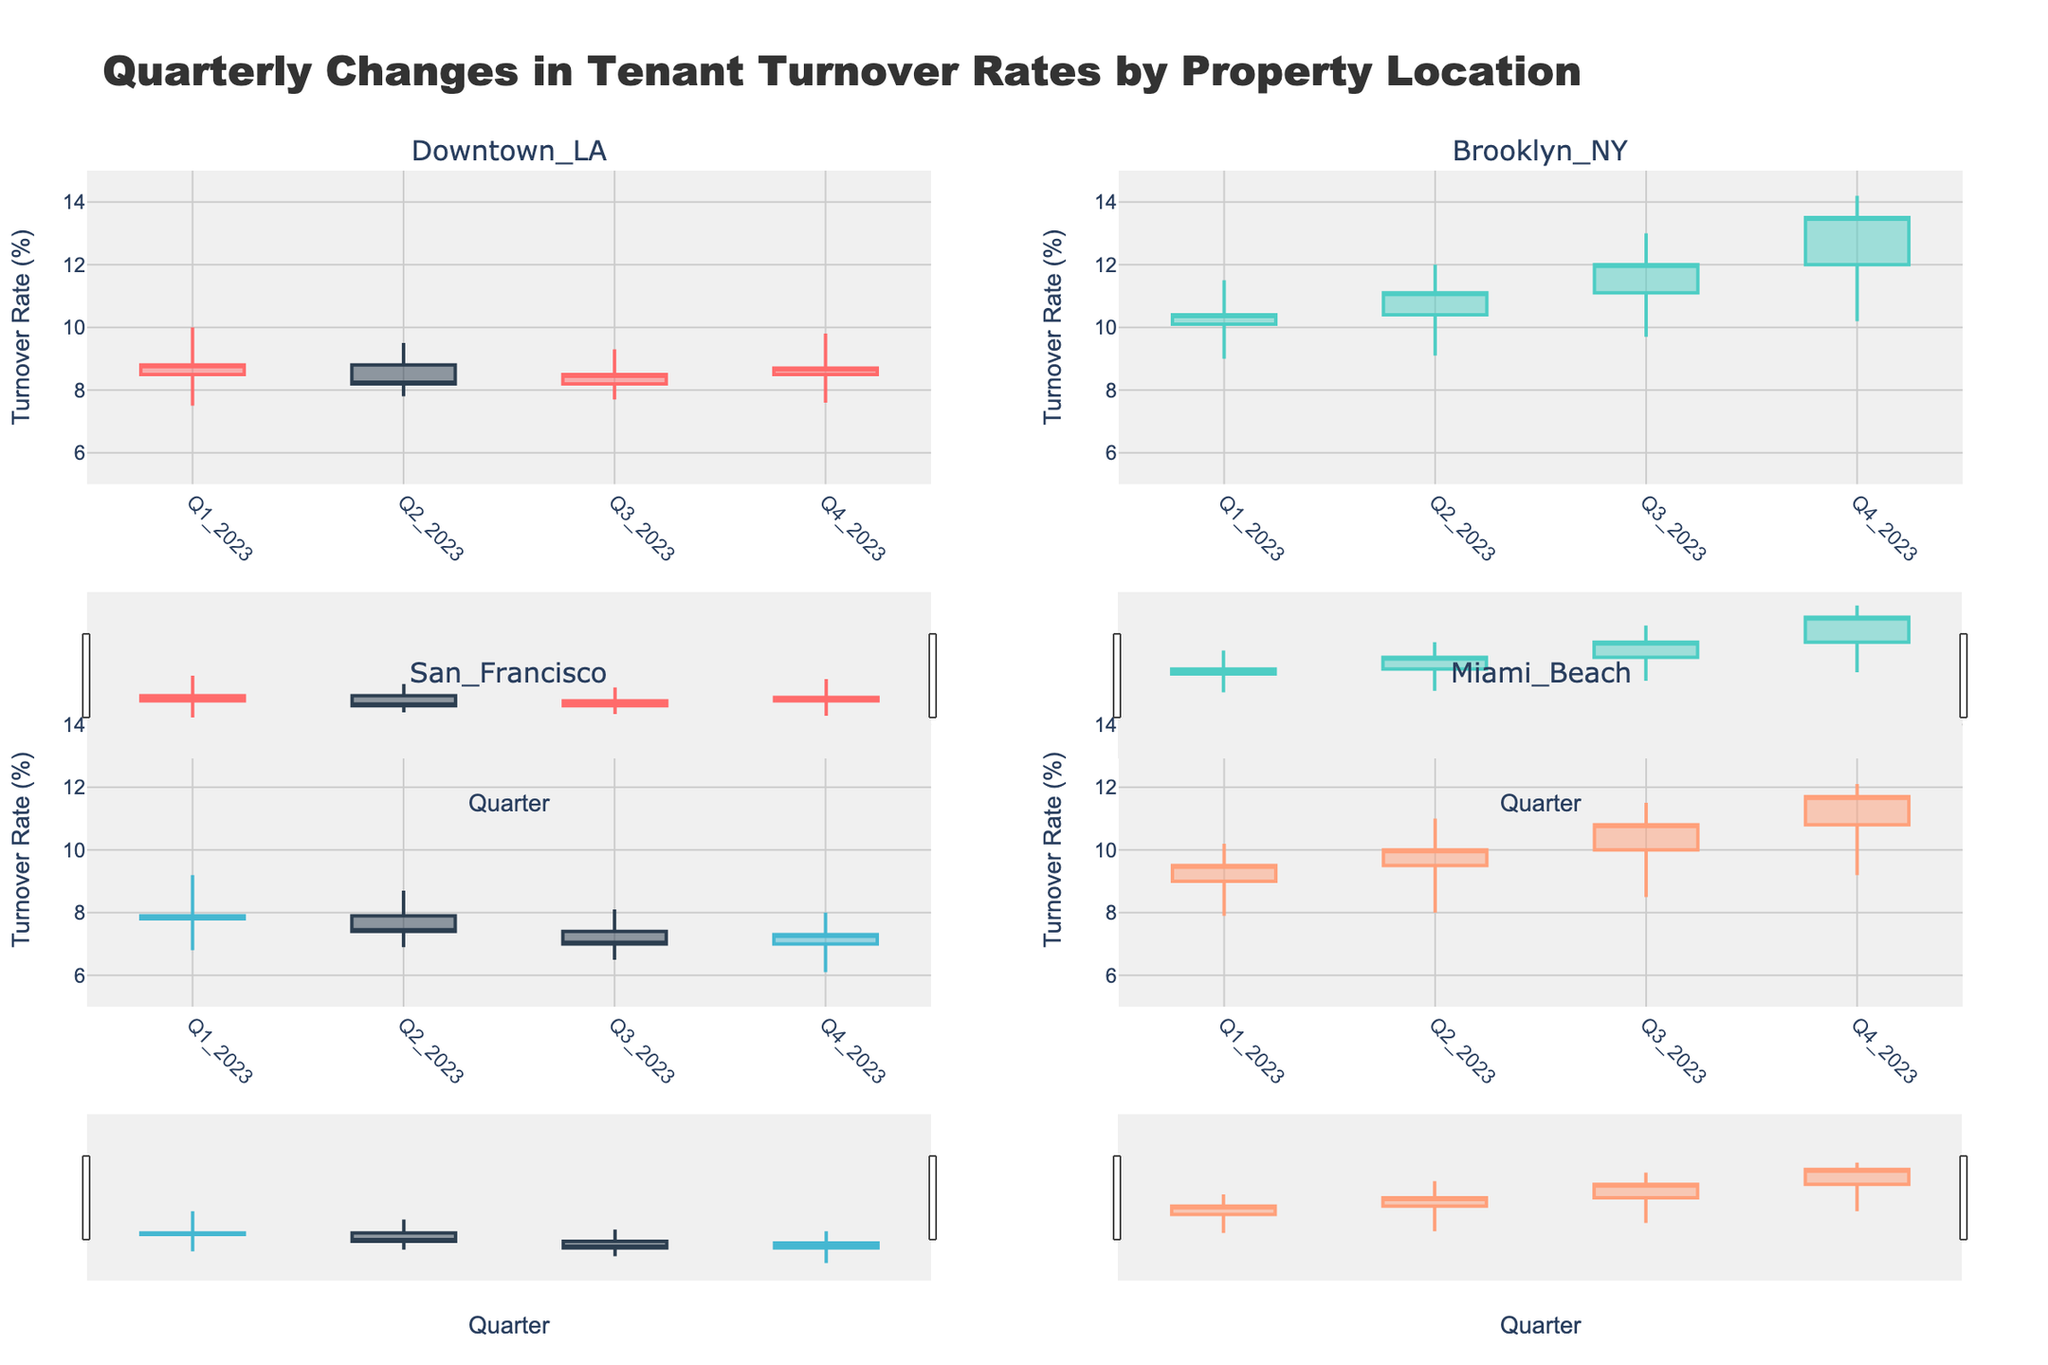what is the title of the plot? The title of the plot is displayed prominently at the top of the figure in larger and bold font. It provides an overview of what the data visualization represents.
Answer: Quarterly Changes in Tenant Turnover Rates by Property Location What is the range of the y-axis? The range of the y-axis can be determined by looking at the scale presented alongside it. In this plot, it starts from 5% and goes up to 15%.
Answer: 5% to 15% Which property location showed the highest turnover rate in Q4 2023? By checking the candlestick on the plot corresponding to Q4 2023, we can observe the upper bound of the highest "High" value. Brooklyn, NY had the highest turnover rate in Q4 2023, reaching up to 14.2%.
Answer: Brooklyn, NY What is the color used for the increasing candlestick lines in San Francisco? By matching the location name San Francisco to the corresponding candlestick color, we notice that the increasing candlestick lines are shown in a specific color.
Answer: Light blue Which quarter had the lowest turnover rate for Miami Beach and what was the rate? To find this, we need to review the candlestick for Miami Beach across all quarters and identify the lowest "Low" value. The lowest rate occurred in Q1 2023, with a value of 7.9%.
Answer: Q1 2023, 7.9% Compare the average closing turnover rate for Downtown LA and Brooklyn, NY over the 2023 period. Which one is lower? To compute the average closing rate, sum all closing rates for each location and divide by the number of quarters. Downtown LA: (8.8 + 8.2 + 8.5 + 8.7)/4 = 8.55. Brooklyn, NY: (10.4 + 11.1 + 12.0 + 13.5)/4 = 11.75. Downtown LA has the lower average closing rate.
Answer: Downtown LA Did San Francisco experience an increase in the turnover rate between Q1 2023 and Q4 2023? By looking at the closing rates for Q1 2023 and Q4 2023 on the candlestick chart, we see that the closing rate decreases from 7.9% to 7.3%, indicating no increase.
Answer: No What trend can you observe about Brooklyn, NY's turnover rates over the four quarters? Observing the closing values from Q1 to Q4 2023, we notice that the rates keep increasing sequentially from 10.4% to 13.5%, indicating a consistent upward trend.
Answer: Consistent increase 